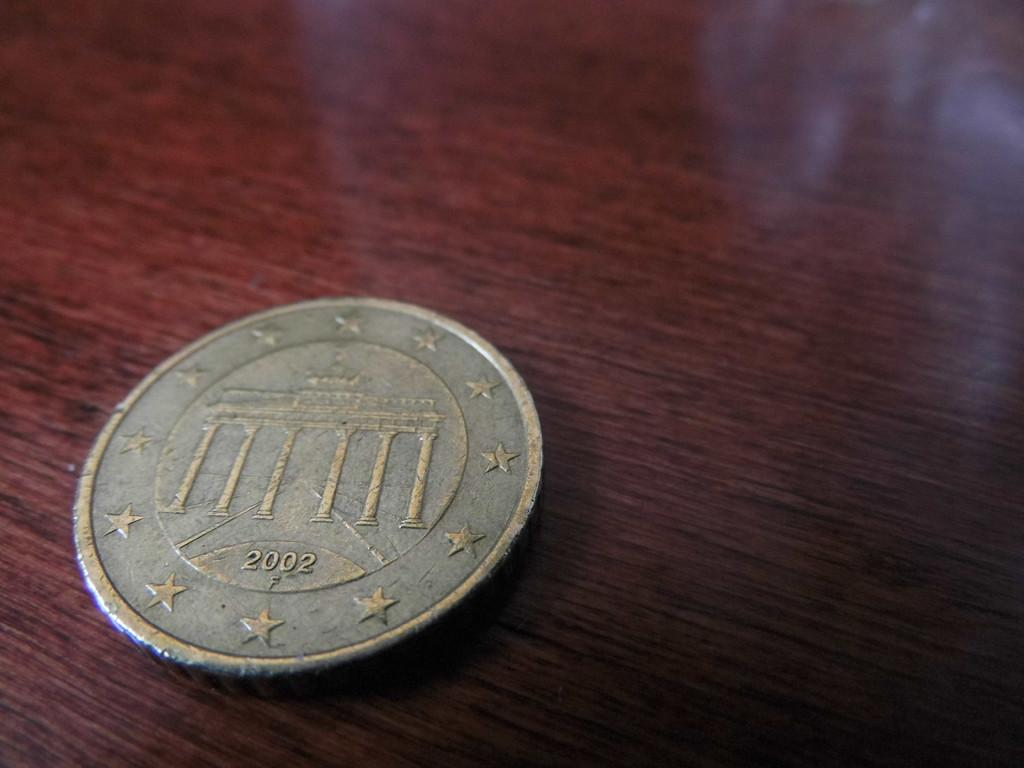<image>
Give a short and clear explanation of the subsequent image. A worn down silver colored coin from 2002 with stars around the perimeter. 